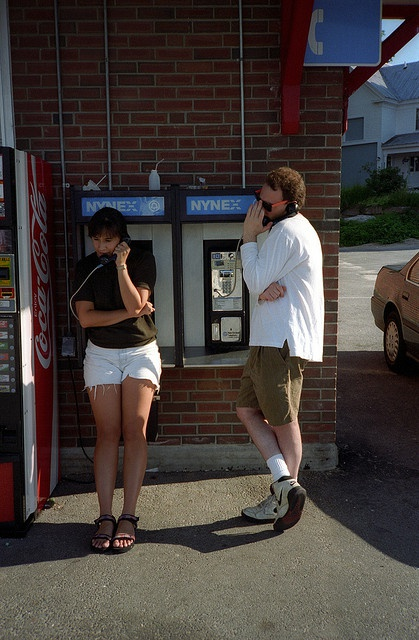Describe the objects in this image and their specific colors. I can see people in black, darkgray, white, and gray tones, people in black, maroon, and darkgray tones, refrigerator in black, gray, maroon, and white tones, car in black, maroon, and gray tones, and bottle in black, gray, and blue tones in this image. 